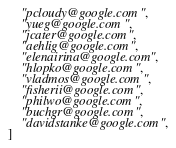Convert code to text. <code><loc_0><loc_0><loc_500><loc_500><_Python_>    "pcloudy@google.com",
    "yueg@google.com",
    "jcater@google.com",
    "aehlig@google.com",
    "elenairina@google.com",
    "hlopko@google.com",
    "vladmos@google.com",
    "fisherii@google.com",
    "philwo@google.com",
    "buchgr@google.com",
    "davidstanke@google.com",
]
</code> 